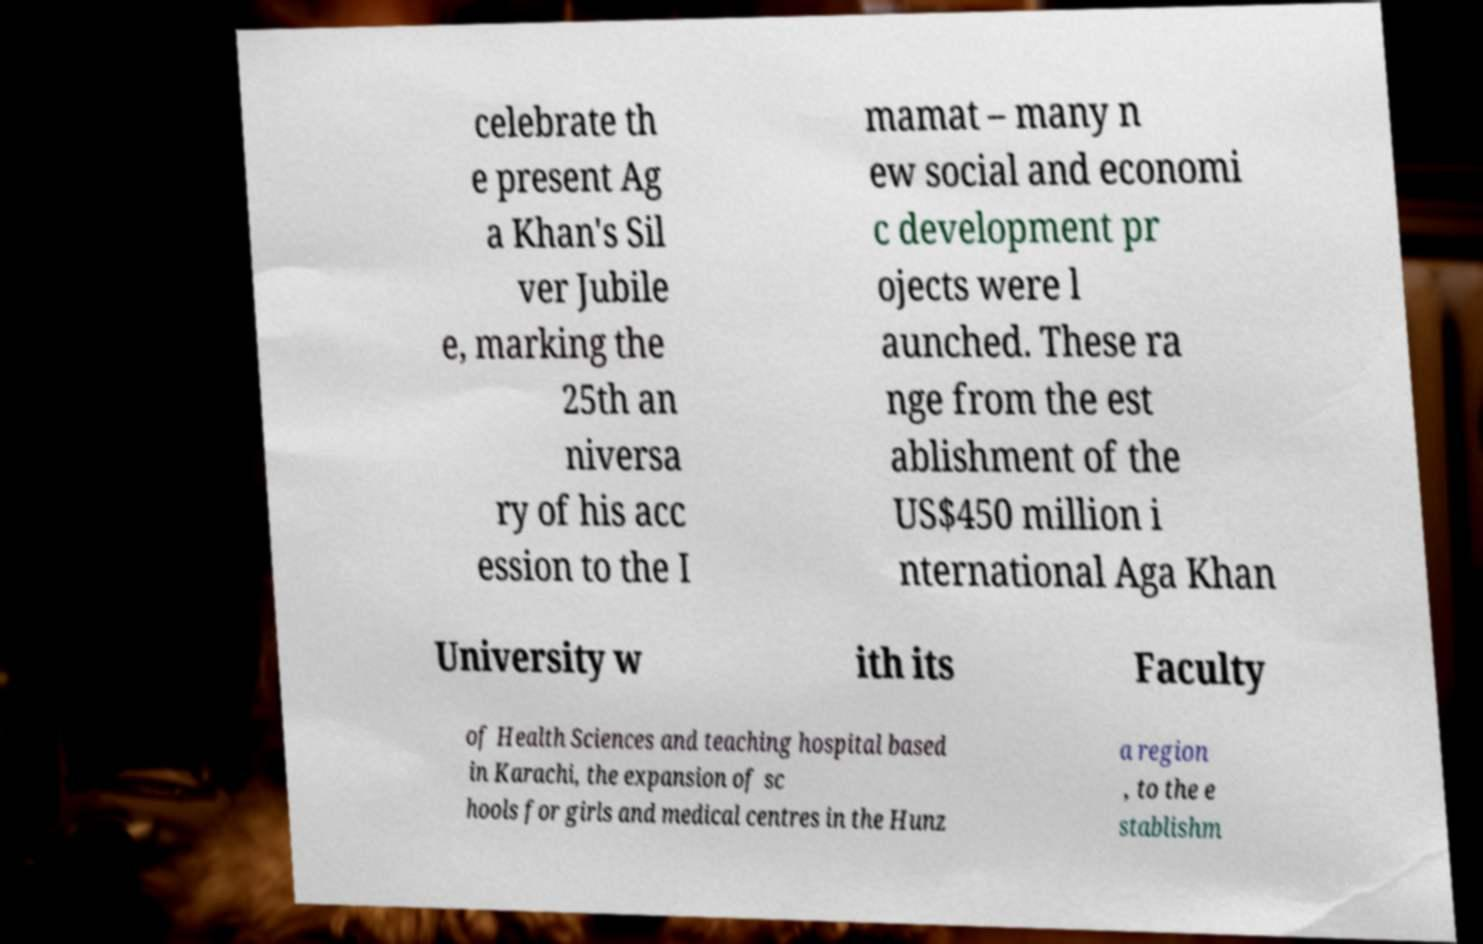Can you read and provide the text displayed in the image?This photo seems to have some interesting text. Can you extract and type it out for me? celebrate th e present Ag a Khan's Sil ver Jubile e, marking the 25th an niversa ry of his acc ession to the I mamat – many n ew social and economi c development pr ojects were l aunched. These ra nge from the est ablishment of the US$450 million i nternational Aga Khan University w ith its Faculty of Health Sciences and teaching hospital based in Karachi, the expansion of sc hools for girls and medical centres in the Hunz a region , to the e stablishm 